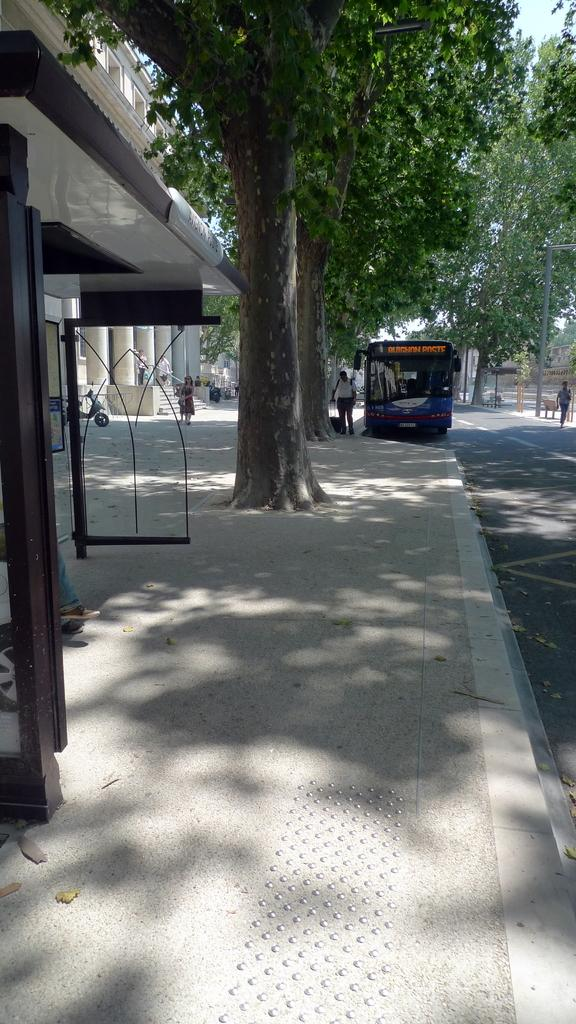What type of pathway is visible in the image? There is a sidewalk in the image. What structure can be seen near the sidewalk? There is a bus shelter in the image. What type of vegetation is present in the image? There are trees in the image. What mode of transportation is on the road in the image? There is a bus on the road in the image. What type of personal transportation device is in the image? There is a scooter in the image. What architectural feature can be seen in the background of the image? There are steps in the background of the image. What object is present in the background of the image? There is a pole in the background of the image. How many geese are sitting on the branch in the image? There are no geese or branches present in the image. What type of arch can be seen in the background of the image? There is no arch present in the image. 